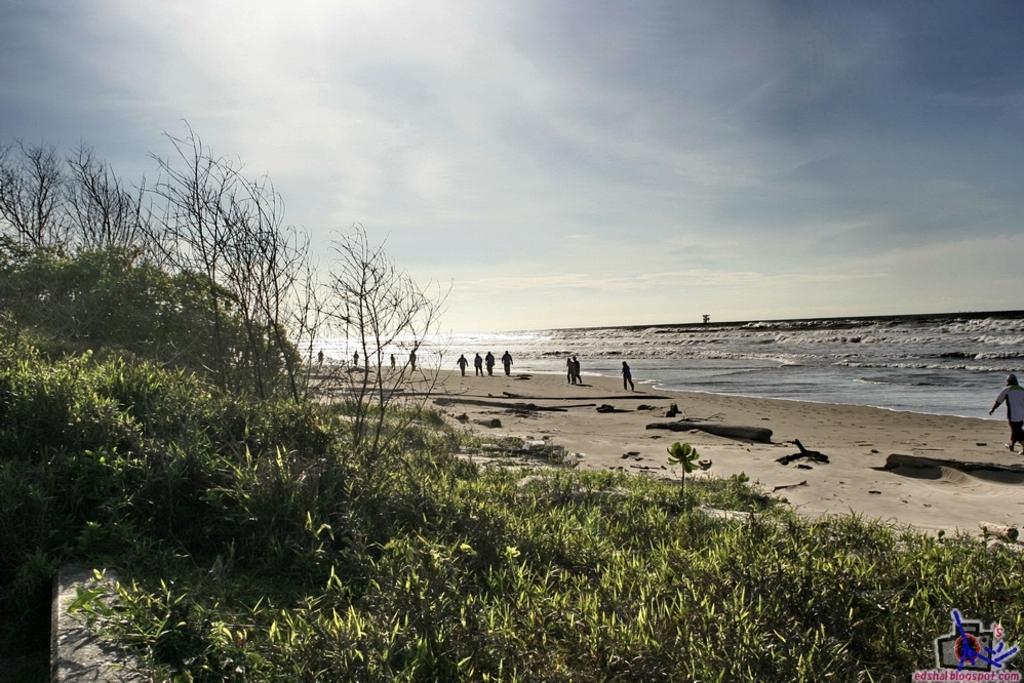Could you give a brief overview of what you see in this image? In this image I can see few trees and grass in the front. In the background I can see number of people are standing on the ground. I can also see water, clouds and the sky in the background. On the bottom right side of this image I can see a watermark. 